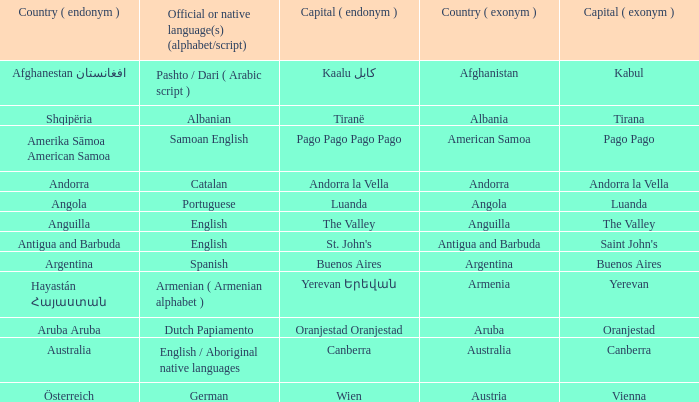What is the local name given to the capital of Anguilla? The Valley. 